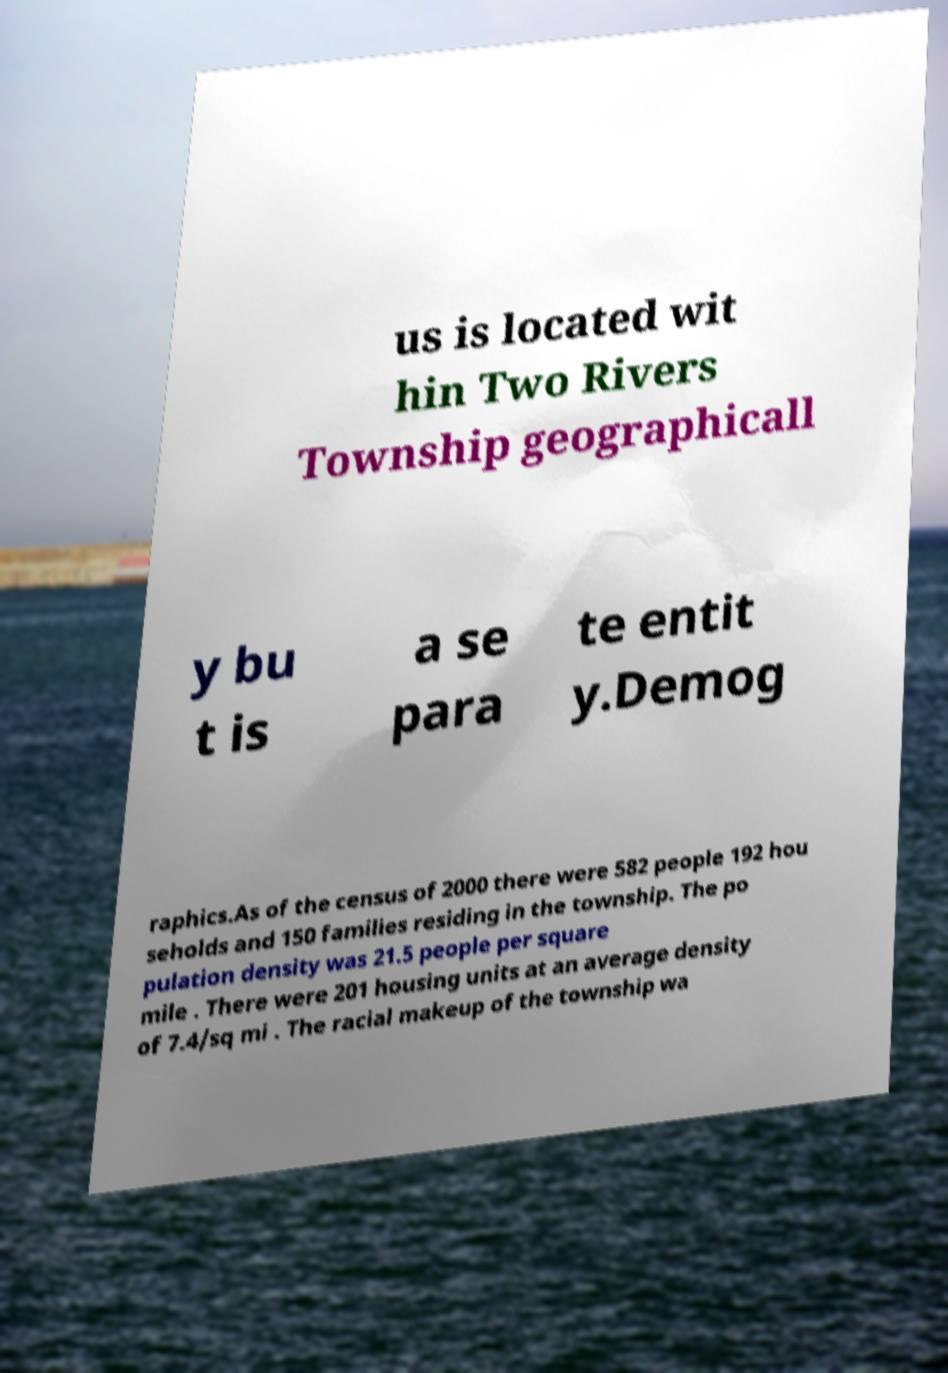Can you read and provide the text displayed in the image?This photo seems to have some interesting text. Can you extract and type it out for me? us is located wit hin Two Rivers Township geographicall y bu t is a se para te entit y.Demog raphics.As of the census of 2000 there were 582 people 192 hou seholds and 150 families residing in the township. The po pulation density was 21.5 people per square mile . There were 201 housing units at an average density of 7.4/sq mi . The racial makeup of the township wa 